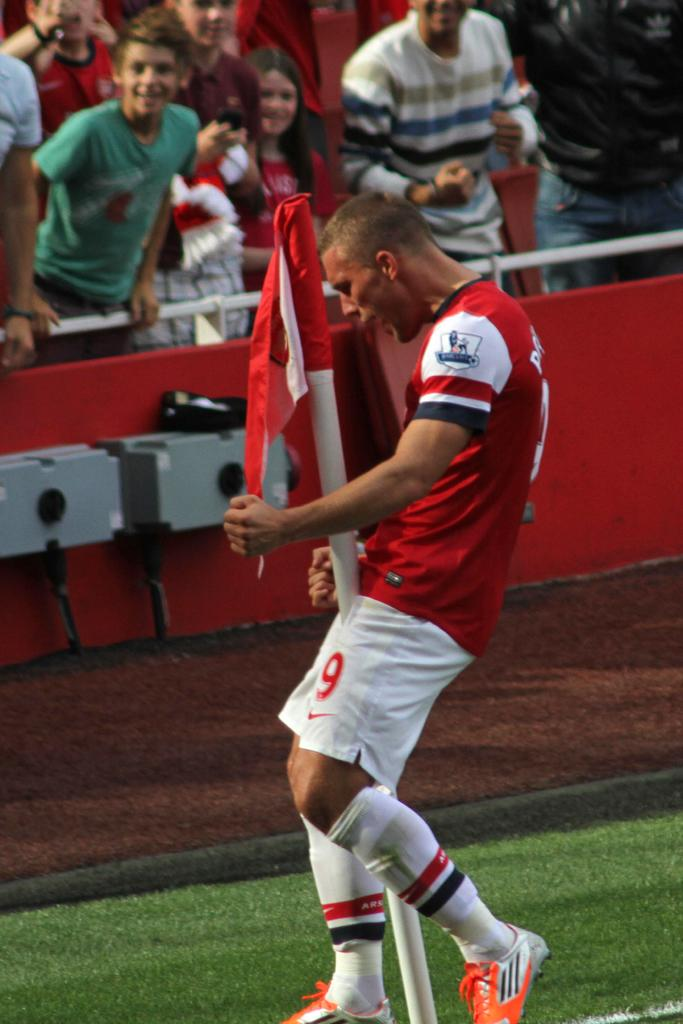<image>
Create a compact narrative representing the image presented. A man in white shorts that have a 9 and the Nike logo is on a soccer field 